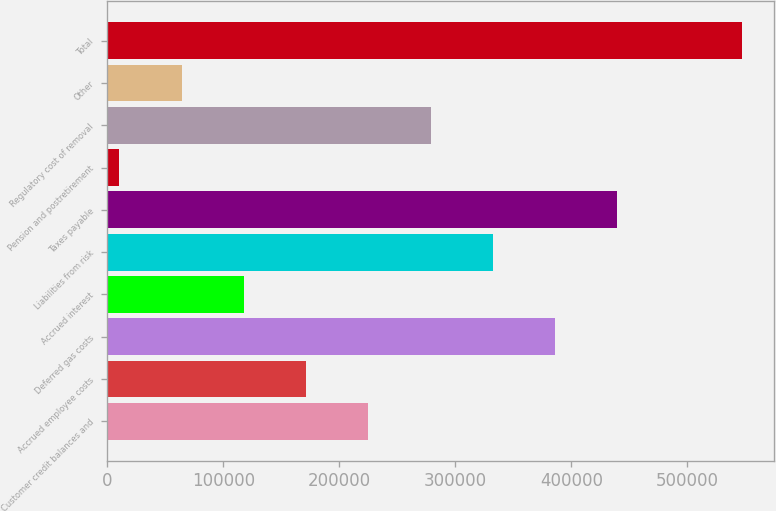<chart> <loc_0><loc_0><loc_500><loc_500><bar_chart><fcel>Customer credit balances and<fcel>Accrued employee costs<fcel>Deferred gas costs<fcel>Accrued interest<fcel>Liabilities from risk<fcel>Taxes payable<fcel>Pension and postretirement<fcel>Regulatory cost of removal<fcel>Other<fcel>Total<nl><fcel>225112<fcel>171453<fcel>386090<fcel>117794<fcel>332431<fcel>439749<fcel>10475<fcel>278772<fcel>64134.3<fcel>547068<nl></chart> 